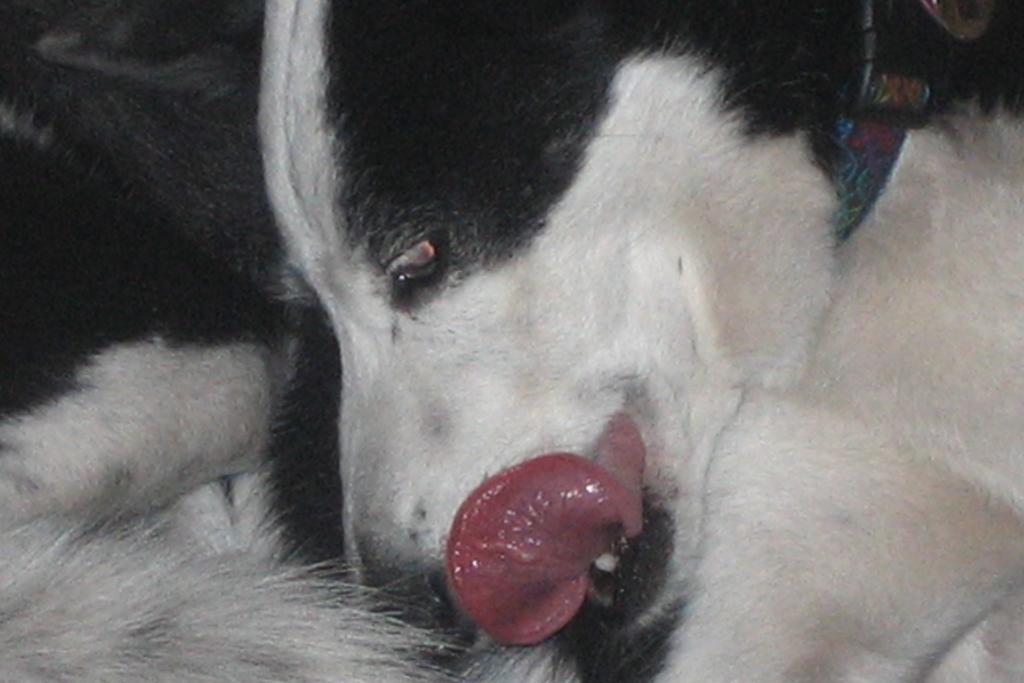What type of animal is in the image? There is a dog in the image. Can you describe the colors of the dog? The dog has white and black colors. Where is the playground located in the image? There is no playground present in the image; it features a dog with white and black colors. What type of scale is used to weigh the father in the image? There is no scale or father present in the image; it features a dog with white and black colors. 